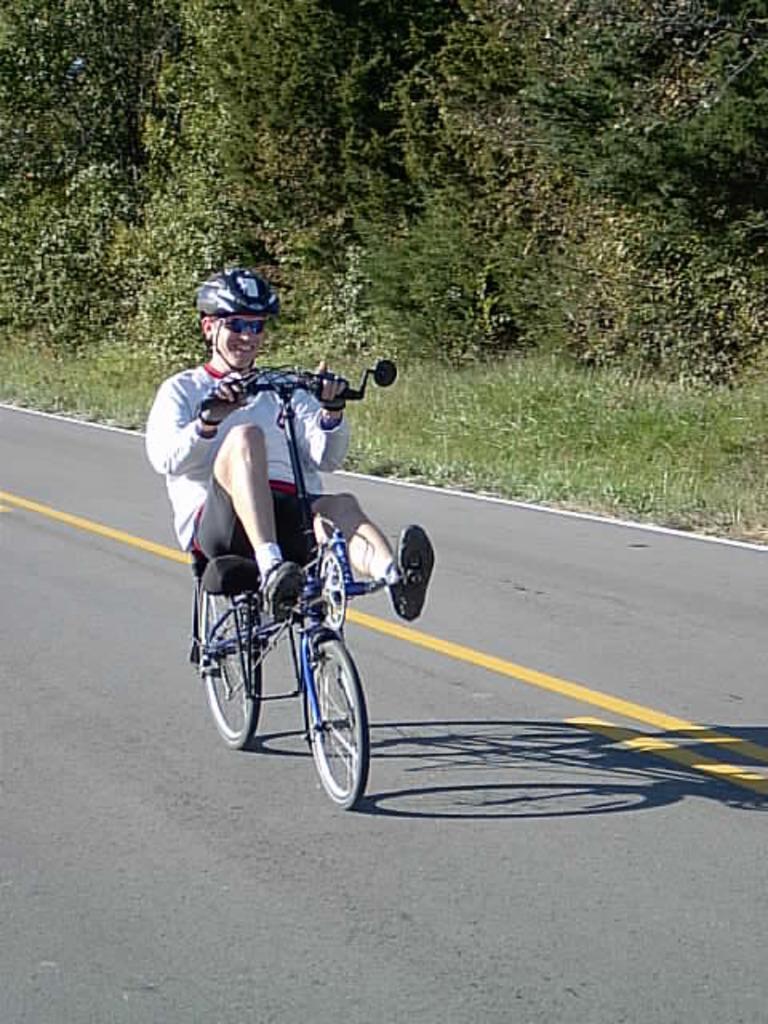How would you summarize this image in a sentence or two? This picture shows a man riding bicycle. He wore a helmet on his head and we see trees and grass 